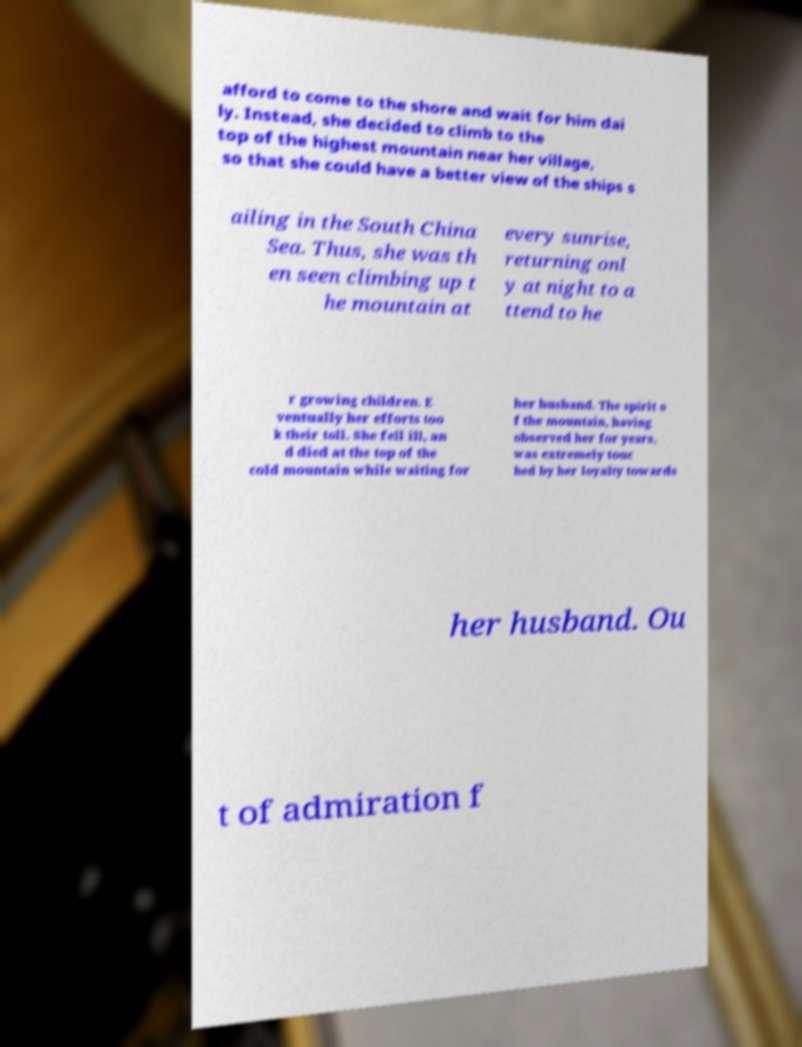Could you assist in decoding the text presented in this image and type it out clearly? afford to come to the shore and wait for him dai ly. Instead, she decided to climb to the top of the highest mountain near her village, so that she could have a better view of the ships s ailing in the South China Sea. Thus, she was th en seen climbing up t he mountain at every sunrise, returning onl y at night to a ttend to he r growing children. E ventually her efforts too k their toll. She fell ill, an d died at the top of the cold mountain while waiting for her husband. The spirit o f the mountain, having observed her for years, was extremely touc hed by her loyalty towards her husband. Ou t of admiration f 